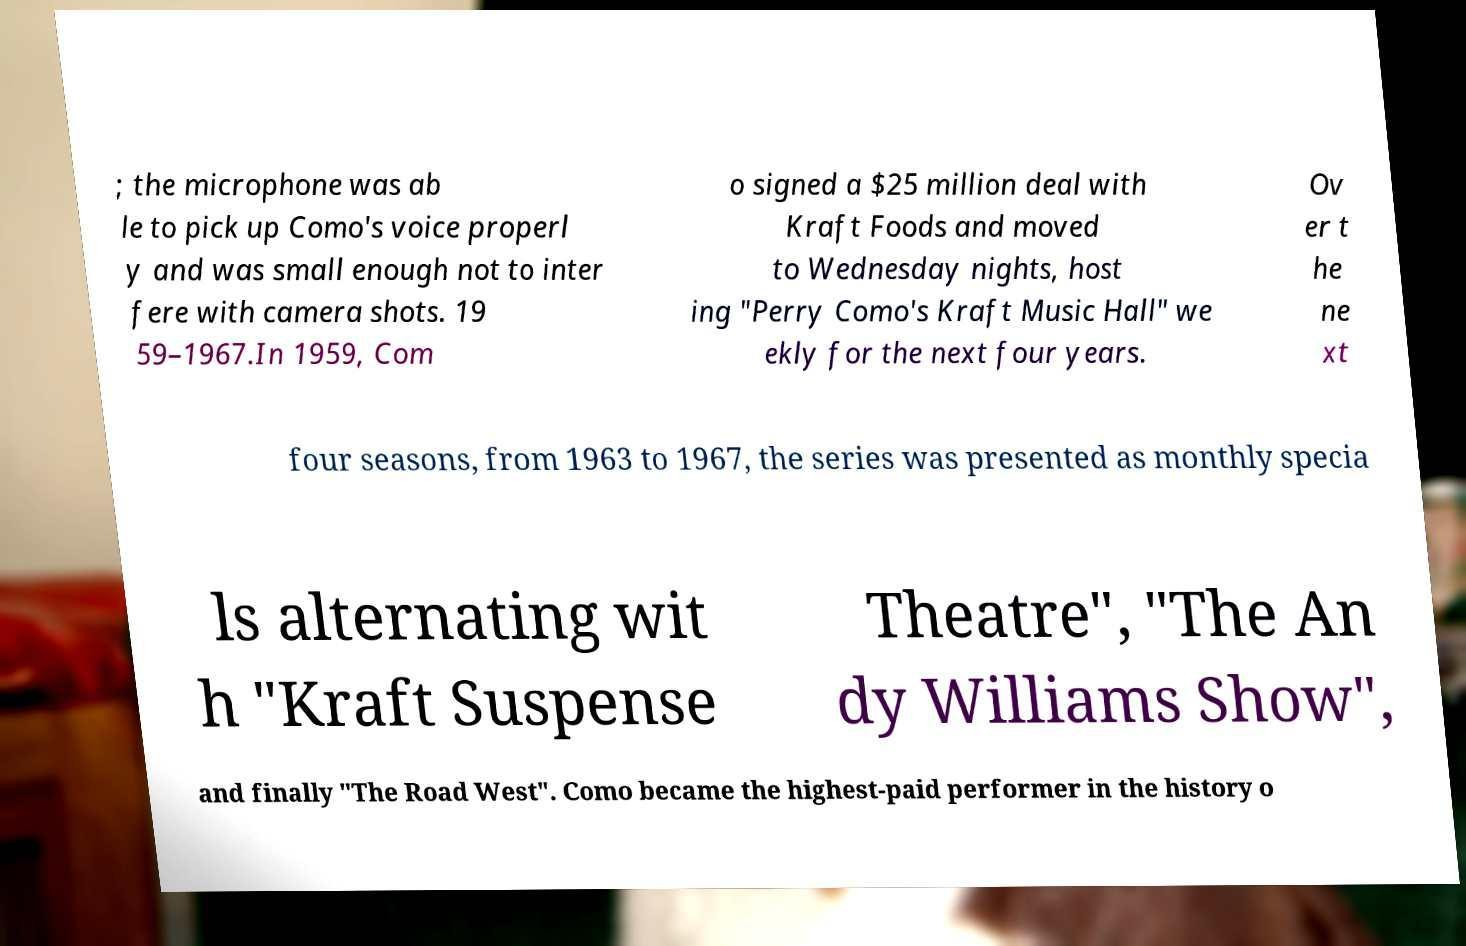Please read and relay the text visible in this image. What does it say? ; the microphone was ab le to pick up Como's voice properl y and was small enough not to inter fere with camera shots. 19 59–1967.In 1959, Com o signed a $25 million deal with Kraft Foods and moved to Wednesday nights, host ing "Perry Como's Kraft Music Hall" we ekly for the next four years. Ov er t he ne xt four seasons, from 1963 to 1967, the series was presented as monthly specia ls alternating wit h "Kraft Suspense Theatre", "The An dy Williams Show", and finally "The Road West". Como became the highest-paid performer in the history o 